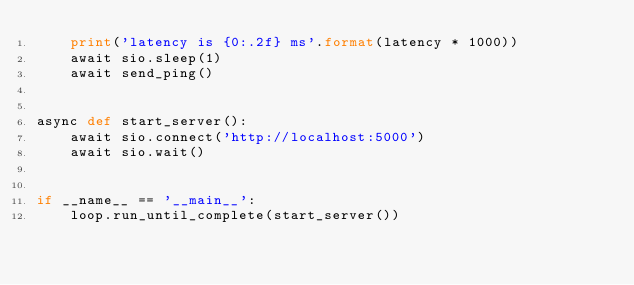Convert code to text. <code><loc_0><loc_0><loc_500><loc_500><_Python_>    print('latency is {0:.2f} ms'.format(latency * 1000))
    await sio.sleep(1)
    await send_ping()


async def start_server():
    await sio.connect('http://localhost:5000')
    await sio.wait()


if __name__ == '__main__':
    loop.run_until_complete(start_server())
</code> 